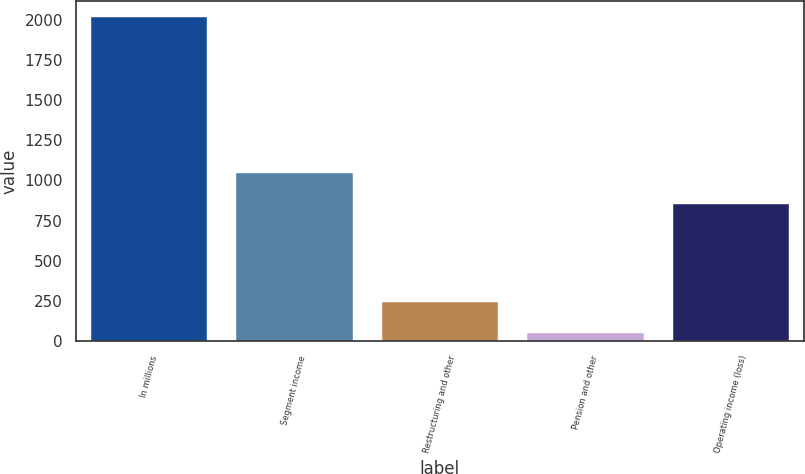Convert chart to OTSL. <chart><loc_0><loc_0><loc_500><loc_500><bar_chart><fcel>In millions<fcel>Segment income<fcel>Restructuring and other<fcel>Pension and other<fcel>Operating income (loss)<nl><fcel>2014<fcel>1048.31<fcel>246.31<fcel>49.9<fcel>851.9<nl></chart> 